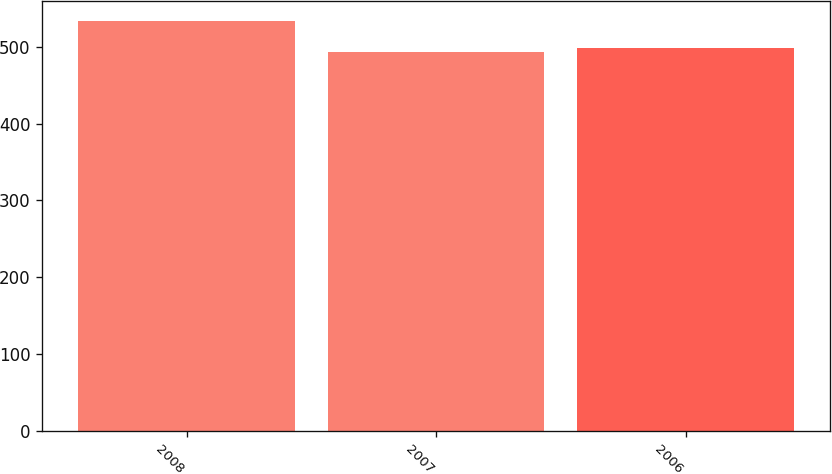<chart> <loc_0><loc_0><loc_500><loc_500><bar_chart><fcel>2008<fcel>2007<fcel>2006<nl><fcel>533<fcel>493<fcel>499<nl></chart> 